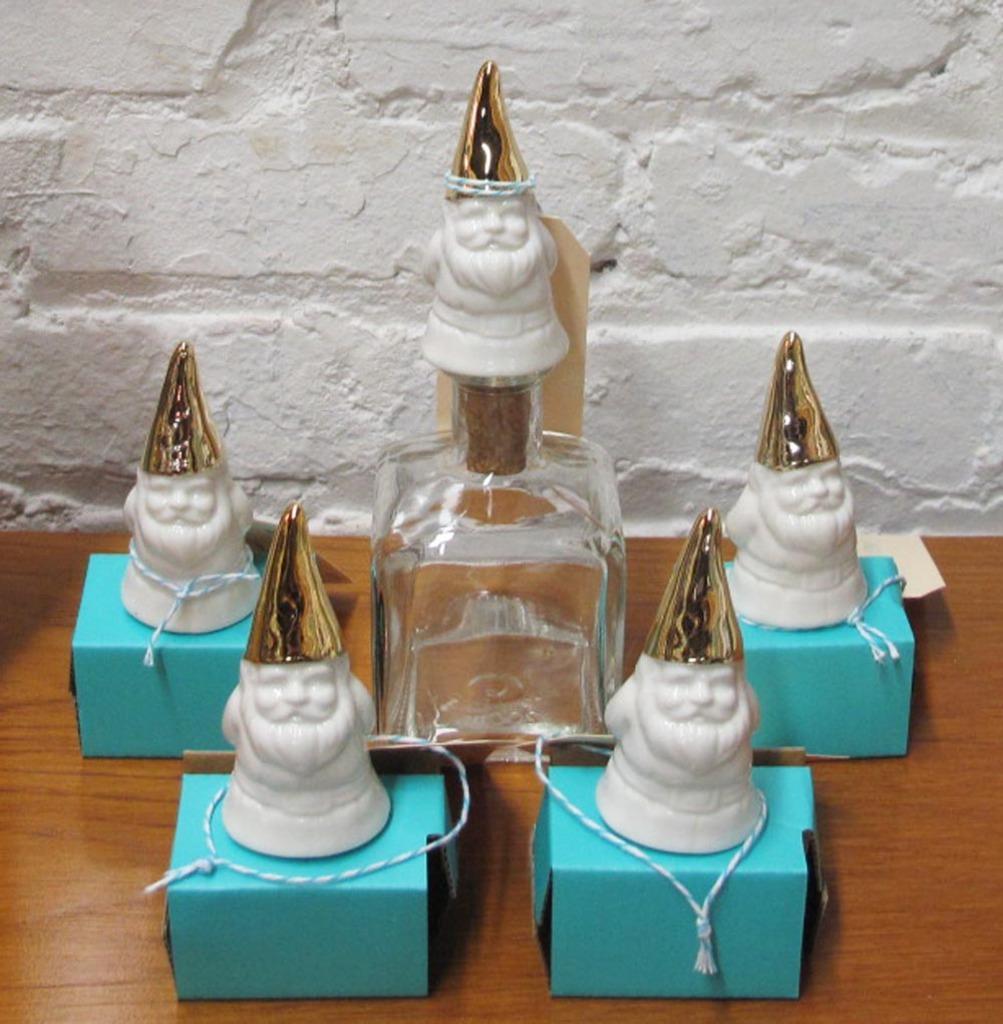In one or two sentences, can you explain what this image depicts? There is a wooden table in the image. On the table there are boxes and a glass bottle. On them there are small sculptures. On the sculpture there is a crown and a thread around them. In the background there is wall. 